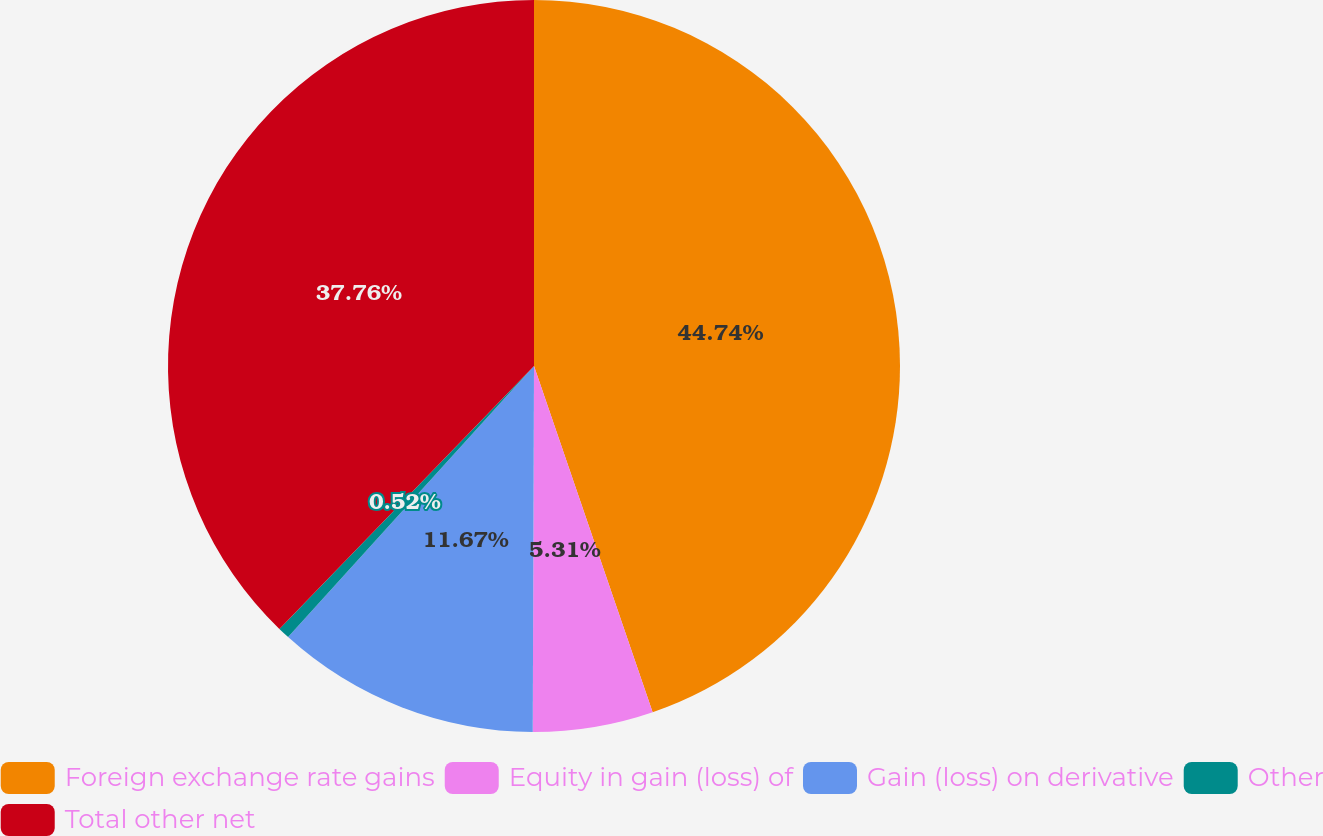Convert chart to OTSL. <chart><loc_0><loc_0><loc_500><loc_500><pie_chart><fcel>Foreign exchange rate gains<fcel>Equity in gain (loss) of<fcel>Gain (loss) on derivative<fcel>Other<fcel>Total other net<nl><fcel>44.75%<fcel>5.31%<fcel>11.67%<fcel>0.52%<fcel>37.76%<nl></chart> 